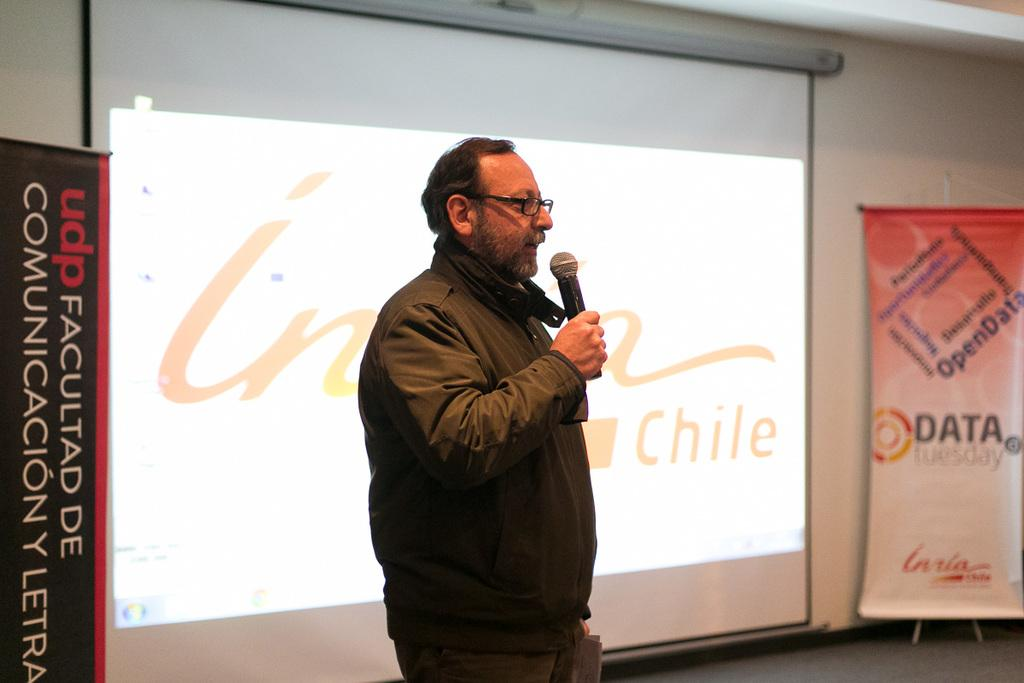<image>
Render a clear and concise summary of the photo. UDP Facultad De Communicacion Y Letra poster and Data Tuesday sign. 